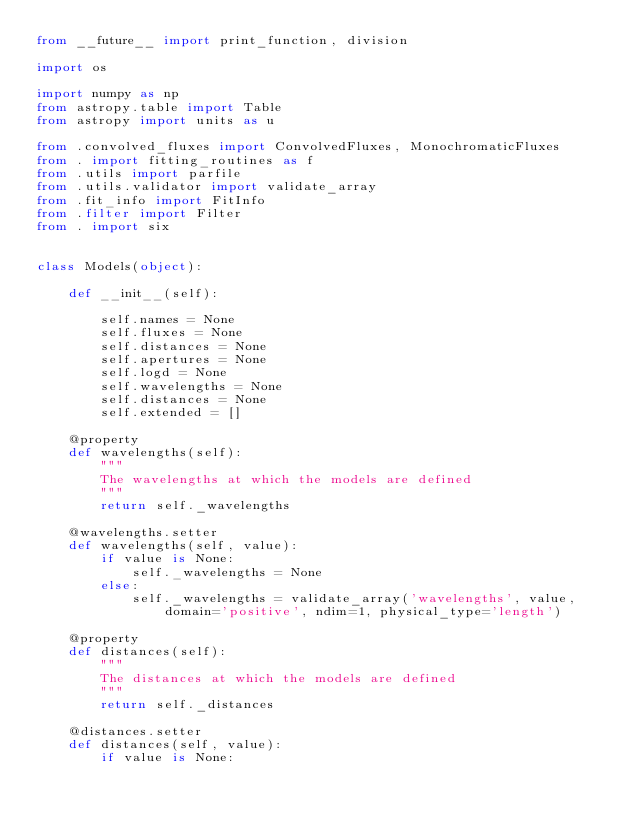<code> <loc_0><loc_0><loc_500><loc_500><_Python_>from __future__ import print_function, division

import os

import numpy as np
from astropy.table import Table
from astropy import units as u

from .convolved_fluxes import ConvolvedFluxes, MonochromaticFluxes
from . import fitting_routines as f
from .utils import parfile
from .utils.validator import validate_array
from .fit_info import FitInfo
from .filter import Filter
from . import six


class Models(object):

    def __init__(self):

        self.names = None
        self.fluxes = None
        self.distances = None
        self.apertures = None
        self.logd = None
        self.wavelengths = None
        self.distances = None
        self.extended = []

    @property
    def wavelengths(self):
        """
        The wavelengths at which the models are defined
        """
        return self._wavelengths

    @wavelengths.setter
    def wavelengths(self, value):
        if value is None:
            self._wavelengths = None
        else:
            self._wavelengths = validate_array('wavelengths', value, domain='positive', ndim=1, physical_type='length')

    @property
    def distances(self):
        """
        The distances at which the models are defined
        """
        return self._distances

    @distances.setter
    def distances(self, value):
        if value is None:</code> 